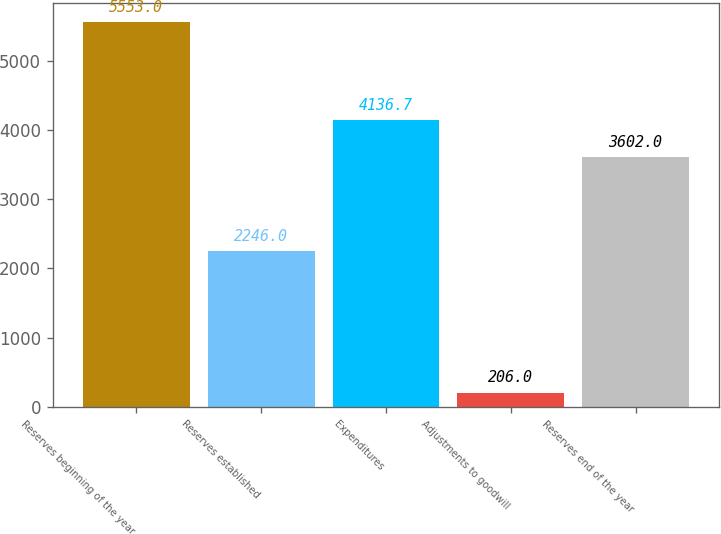Convert chart to OTSL. <chart><loc_0><loc_0><loc_500><loc_500><bar_chart><fcel>Reserves beginning of the year<fcel>Reserves established<fcel>Expenditures<fcel>Adjustments to goodwill<fcel>Reserves end of the year<nl><fcel>5553<fcel>2246<fcel>4136.7<fcel>206<fcel>3602<nl></chart> 